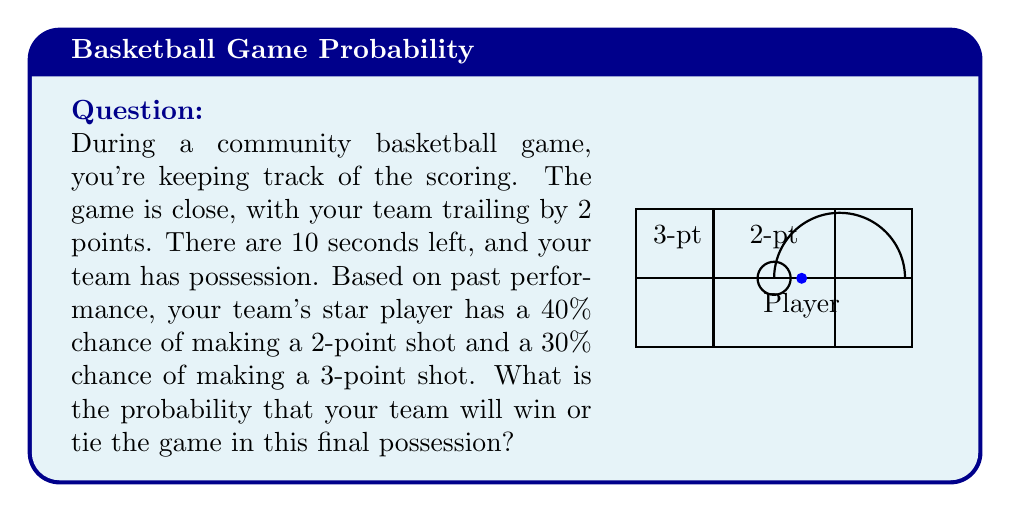Show me your answer to this math problem. Let's break this down step-by-step:

1) There are three possible outcomes:
   - Make a 2-point shot (win)
   - Make a 3-point shot (win)
   - Miss the shot (lose)

2) Probability of making a 2-point shot: 40% = 0.4
3) Probability of making a 3-point shot: 30% = 0.3

4) To calculate the probability of winning or tying:
   $P(\text{win or tie}) = P(\text{2-point}) + P(\text{3-point})$

5) Substituting the values:
   $P(\text{win or tie}) = 0.4 + 0.3 = 0.7$

6) Convert to percentage:
   $0.7 \times 100\% = 70\%$

Therefore, the probability that your team will win or tie the game in this final possession is 70%.
Answer: 70% 